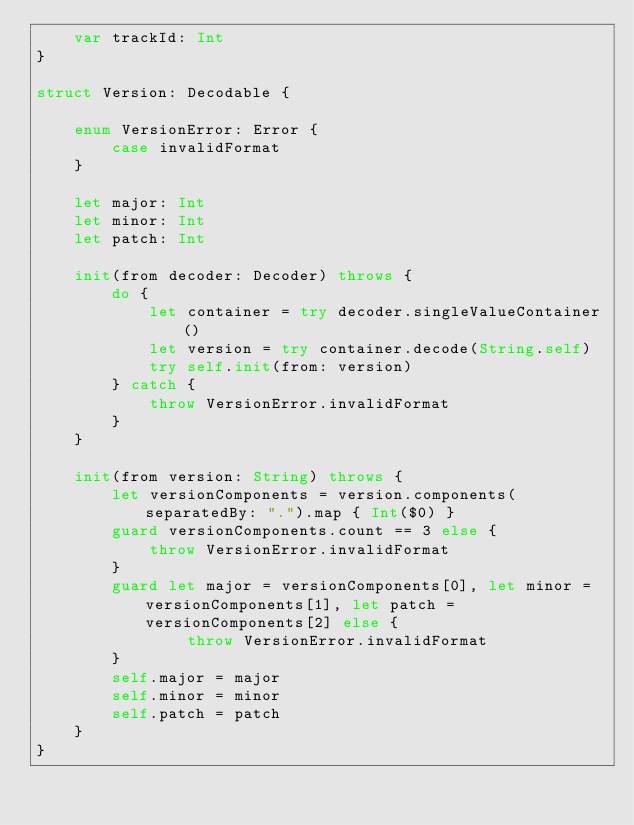Convert code to text. <code><loc_0><loc_0><loc_500><loc_500><_Swift_>    var trackId: Int
}

struct Version: Decodable {

    enum VersionError: Error {
        case invalidFormat
    }

    let major: Int
    let minor: Int
    let patch: Int

    init(from decoder: Decoder) throws {
        do {
            let container = try decoder.singleValueContainer()
            let version = try container.decode(String.self)
            try self.init(from: version)
        } catch {
            throw VersionError.invalidFormat
        }
    }

    init(from version: String) throws {
        let versionComponents = version.components(separatedBy: ".").map { Int($0) }
        guard versionComponents.count == 3 else {
            throw VersionError.invalidFormat
        }
        guard let major = versionComponents[0], let minor = versionComponents[1], let patch = versionComponents[2] else {
                throw VersionError.invalidFormat
        }
        self.major = major
        self.minor = minor
        self.patch = patch
    }
}

</code> 